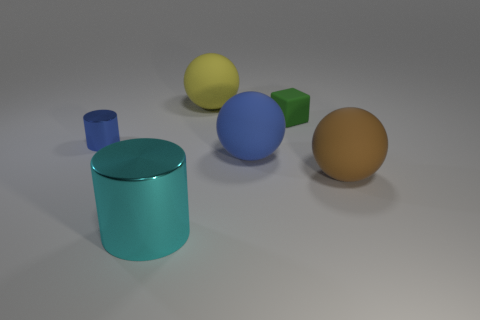Is the number of large green cylinders less than the number of yellow spheres?
Provide a succinct answer. Yes. What is the object that is both left of the yellow object and behind the cyan cylinder made of?
Make the answer very short. Metal. How big is the shiny object that is in front of the small shiny cylinder in front of the large rubber sphere behind the tiny blue thing?
Keep it short and to the point. Large. Is the shape of the tiny blue metal object the same as the green rubber thing left of the big brown thing?
Make the answer very short. No. How many big things are both to the left of the yellow ball and behind the tiny metallic cylinder?
Your response must be concise. 0. What number of brown objects are matte spheres or cubes?
Provide a succinct answer. 1. Does the metal thing that is behind the cyan cylinder have the same color as the big thing that is on the left side of the big yellow ball?
Offer a very short reply. No. What color is the small thing right of the object behind the tiny object right of the yellow rubber thing?
Give a very brief answer. Green. There is a big matte object that is on the left side of the big blue ball; are there any big blue rubber objects that are left of it?
Give a very brief answer. No. Do the blue thing that is to the left of the big yellow ball and the tiny green rubber thing have the same shape?
Offer a terse response. No. 